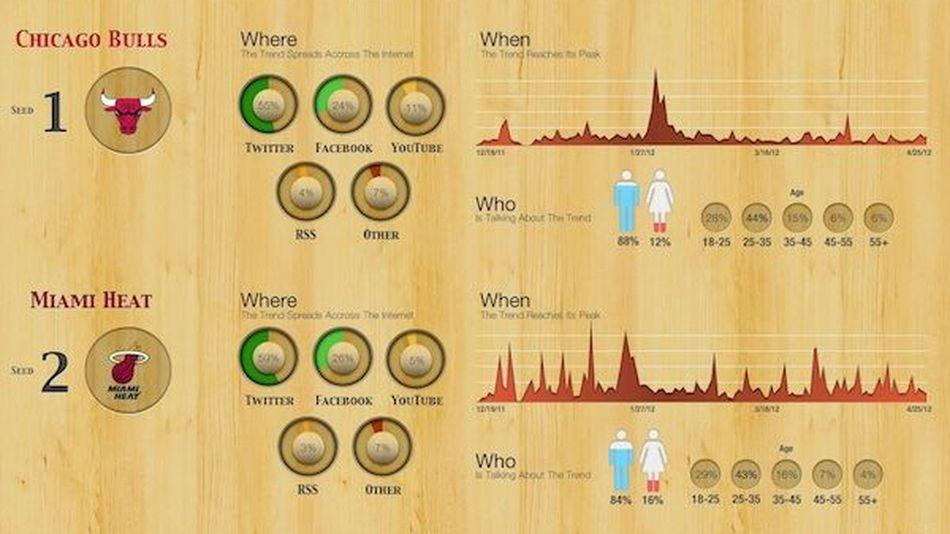Which is more active on you tube
Answer the question with a short phrase. chicago bulls Which trend is more talked about among males chicago bulls Which trend is more talked about among females miami heat What % of females are talking about Chicago bulls 12% 